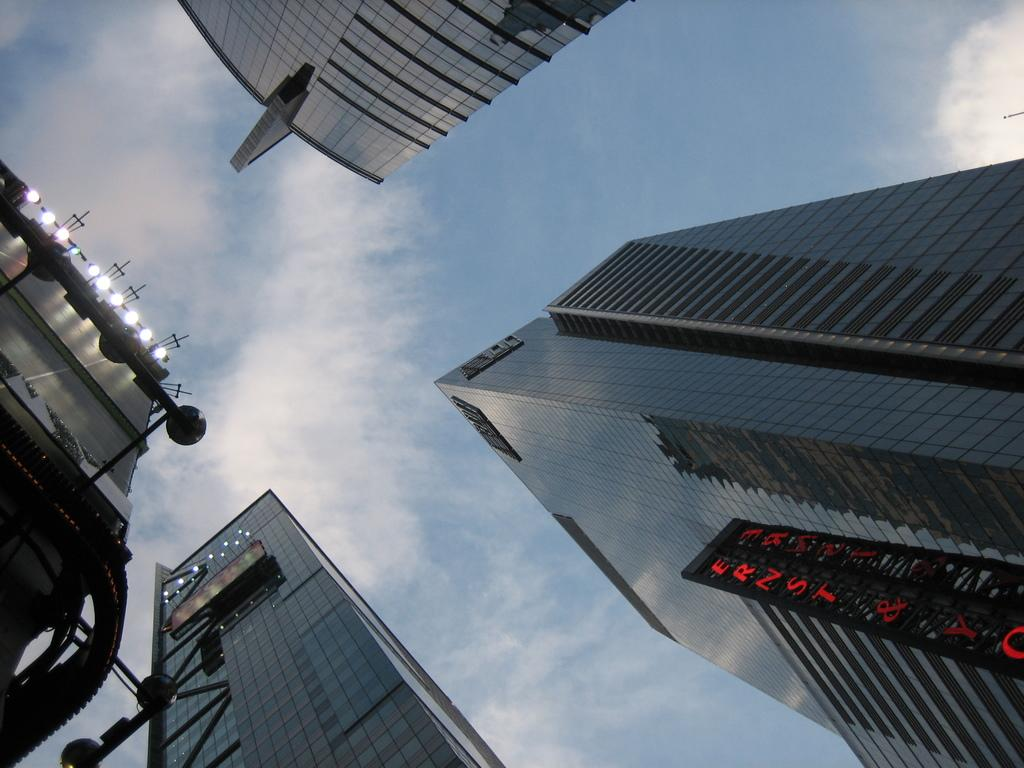What type of structures can be seen in the image? There are buildings in the image. What else is visible in the image besides the buildings? There are lights and the sky in the image. What type of suit is the building wearing in the image? There are no suits present in the image, as buildings do not wear clothing. 